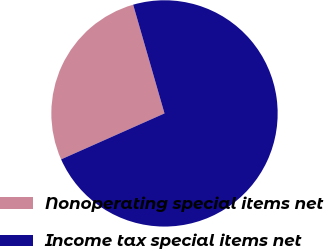Convert chart. <chart><loc_0><loc_0><loc_500><loc_500><pie_chart><fcel>Nonoperating special items net<fcel>Income tax special items net<nl><fcel>27.19%<fcel>72.81%<nl></chart> 